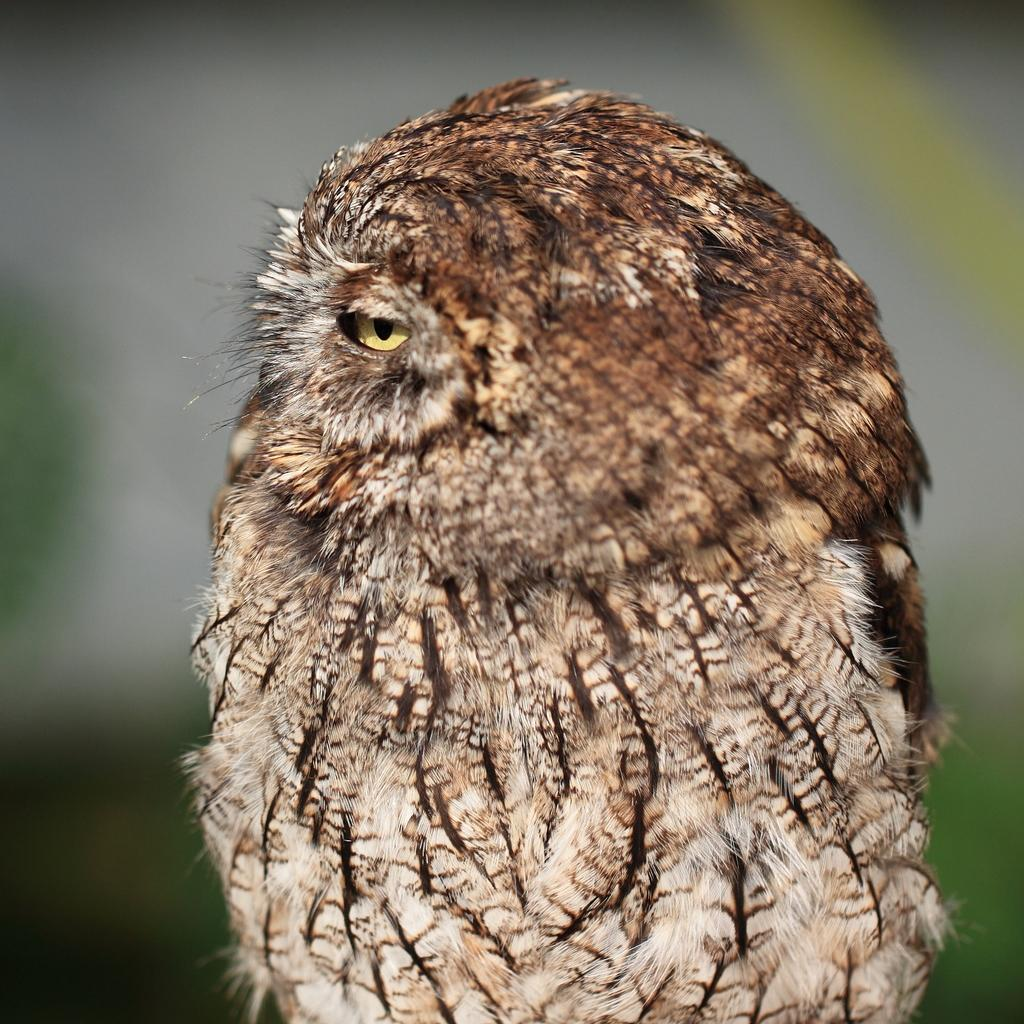What animal is the main subject of the image? There is an owl in the image. Can you describe the background of the image? The background of the image is blurred. How many jellyfish can be seen swimming in the background of the image? There are no jellyfish present in the image; it features an owl with a blurred background. What type of scarf is the farmer wearing in the image? There is no farmer or scarf present in the image; it features an owl with a blurred background. 